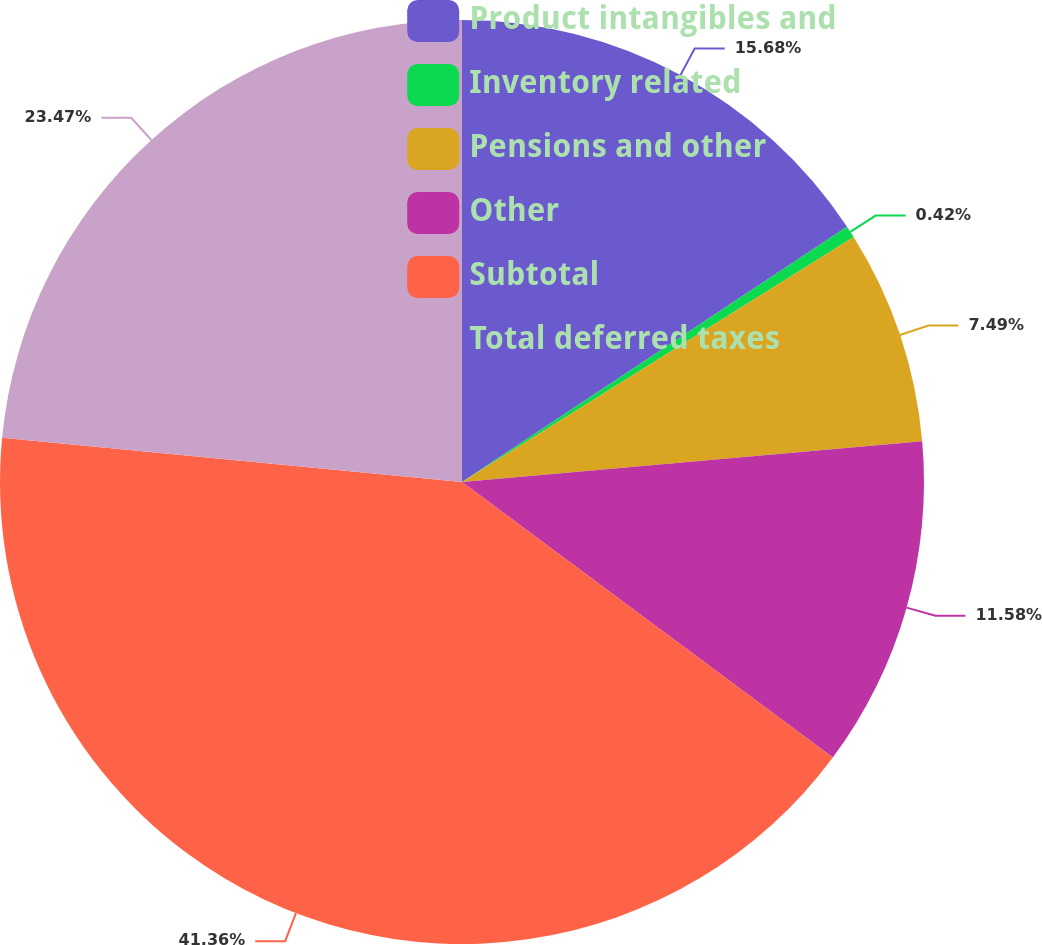<chart> <loc_0><loc_0><loc_500><loc_500><pie_chart><fcel>Product intangibles and<fcel>Inventory related<fcel>Pensions and other<fcel>Other<fcel>Subtotal<fcel>Total deferred taxes<nl><fcel>15.68%<fcel>0.42%<fcel>7.49%<fcel>11.58%<fcel>41.35%<fcel>23.47%<nl></chart> 